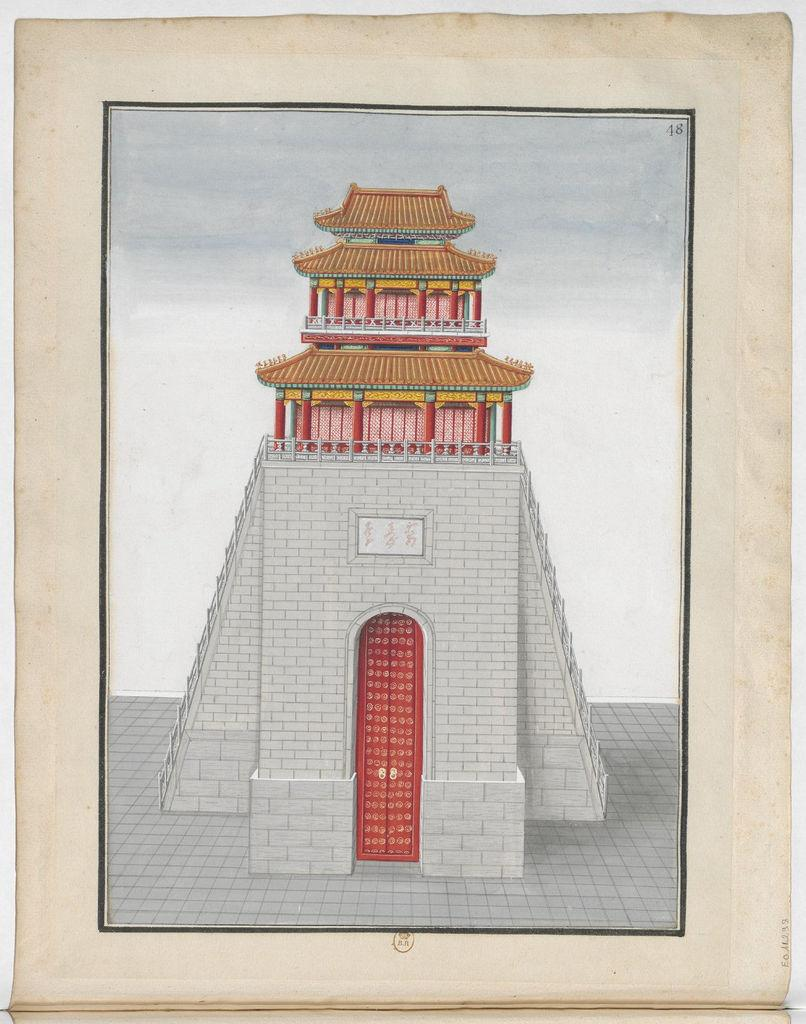What is the main subject of the image? The main subject of the image is an art of a Chinese temple. What specific feature of the temple is depicted in the art? The art depicts a big door. What material does the art appear to be created on? The art appears to be on paper. What type of sponge can be seen being used to clean the temple in the image? There is no sponge or cleaning activity depicted in the image; it features an art of a Chinese temple with a big door. What type of apparel are the people in the image wearing? There are no people present in the image, as it features an art of a Chinese temple with a big door. What is the reason for the people in the image laughing? There are no people present in the image, and therefore no laughter can be observed. 